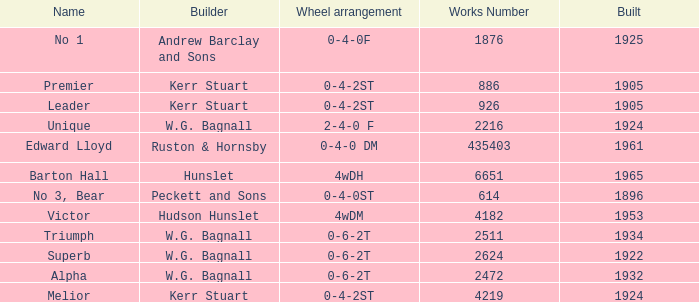What is the average building year for Superb? 1922.0. 